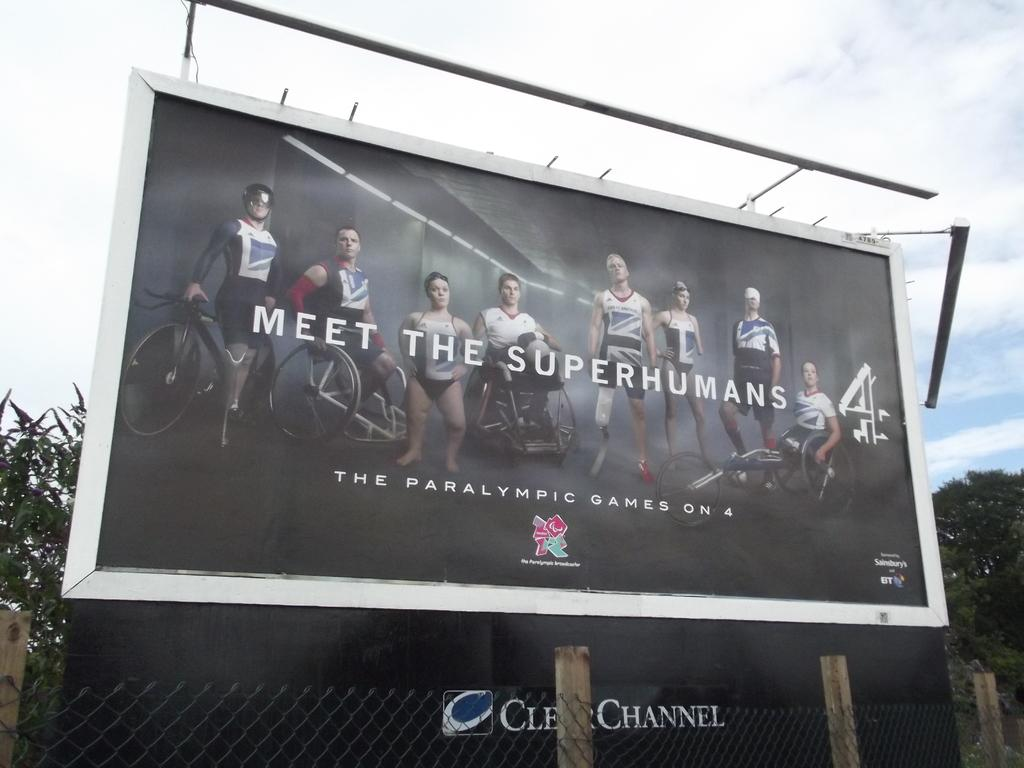<image>
Present a compact description of the photo's key features. A billboard for the Paralympic Games on 4 above a clear channel ad. 